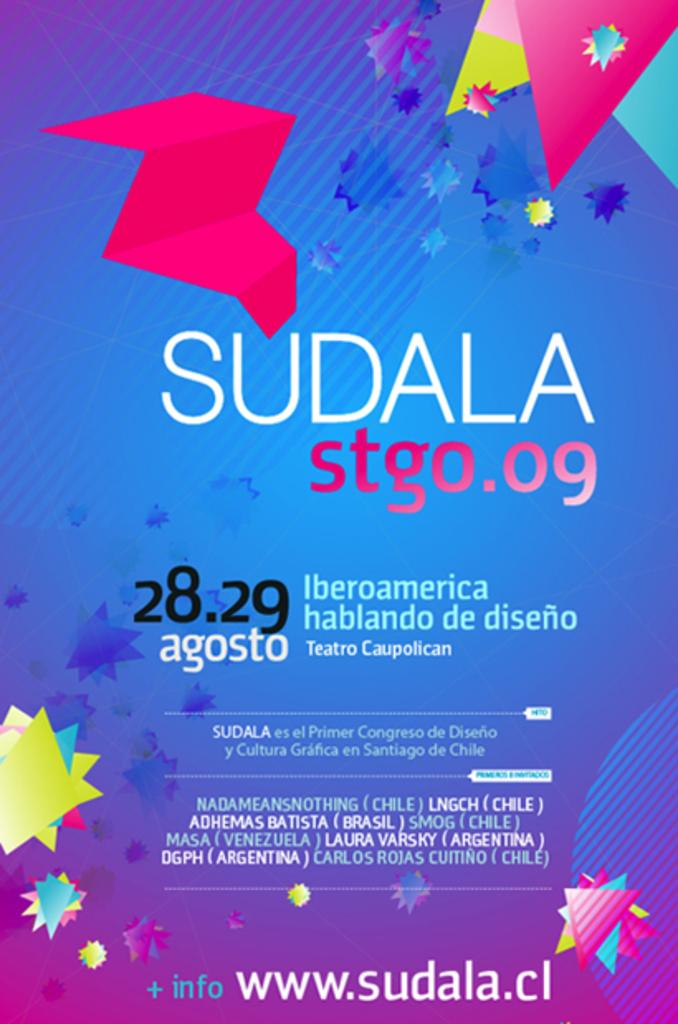<image>
Render a clear and concise summary of the photo. An event called SUDALA took place on August 28th and 29th, according to its poster. 